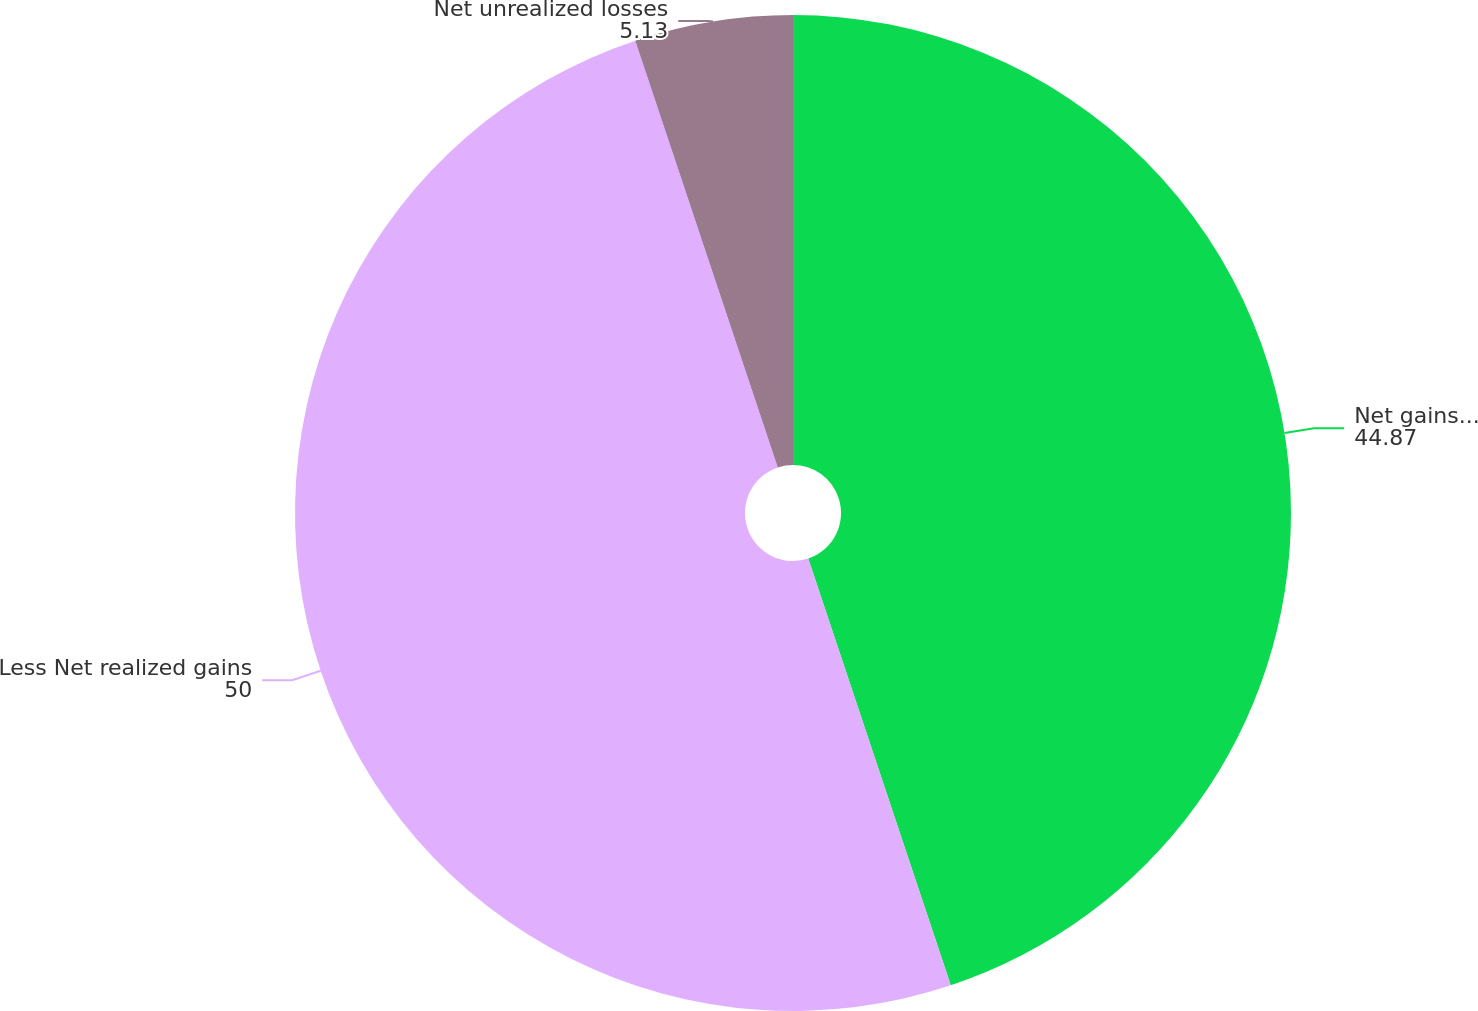Convert chart to OTSL. <chart><loc_0><loc_0><loc_500><loc_500><pie_chart><fcel>Net gains recognized during<fcel>Less Net realized gains<fcel>Net unrealized losses<nl><fcel>44.87%<fcel>50.0%<fcel>5.13%<nl></chart> 